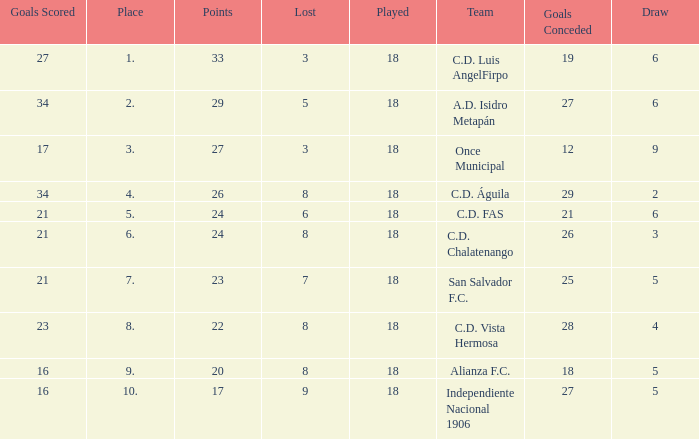How many points were in a game that had a lost of 5, greater than place 2, and 27 goals conceded? 0.0. 